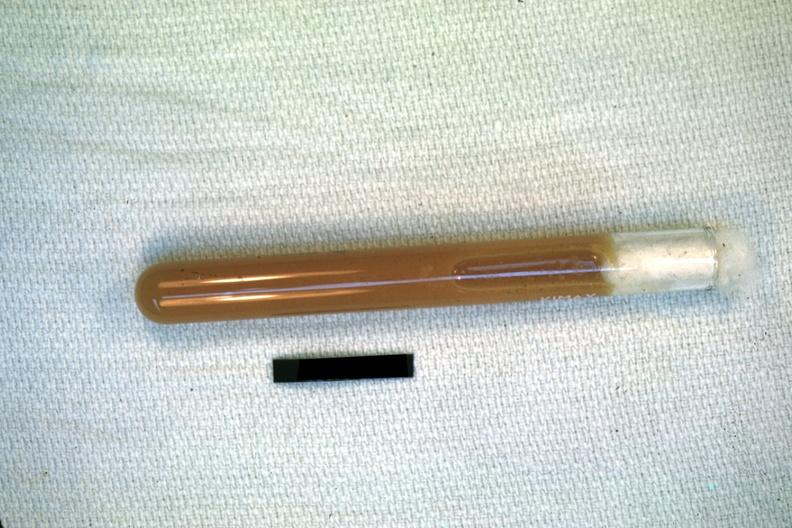what is present?
Answer the question using a single word or phrase. Pus in test tube 